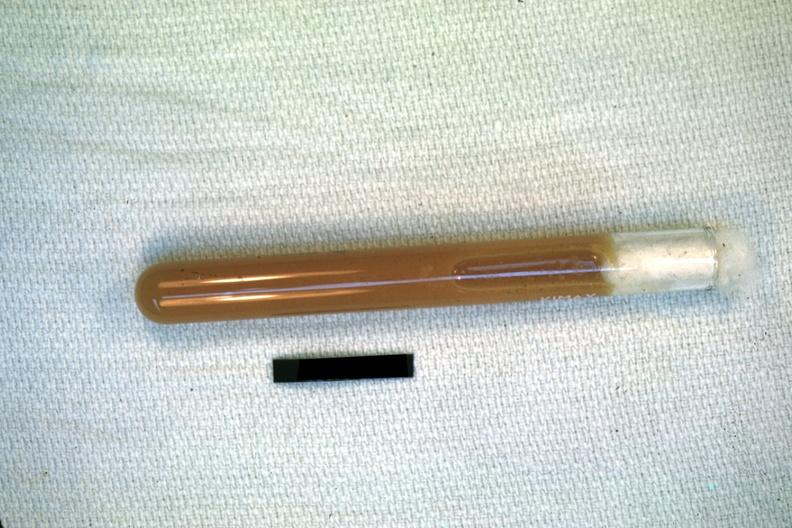what is present?
Answer the question using a single word or phrase. Pus in test tube 